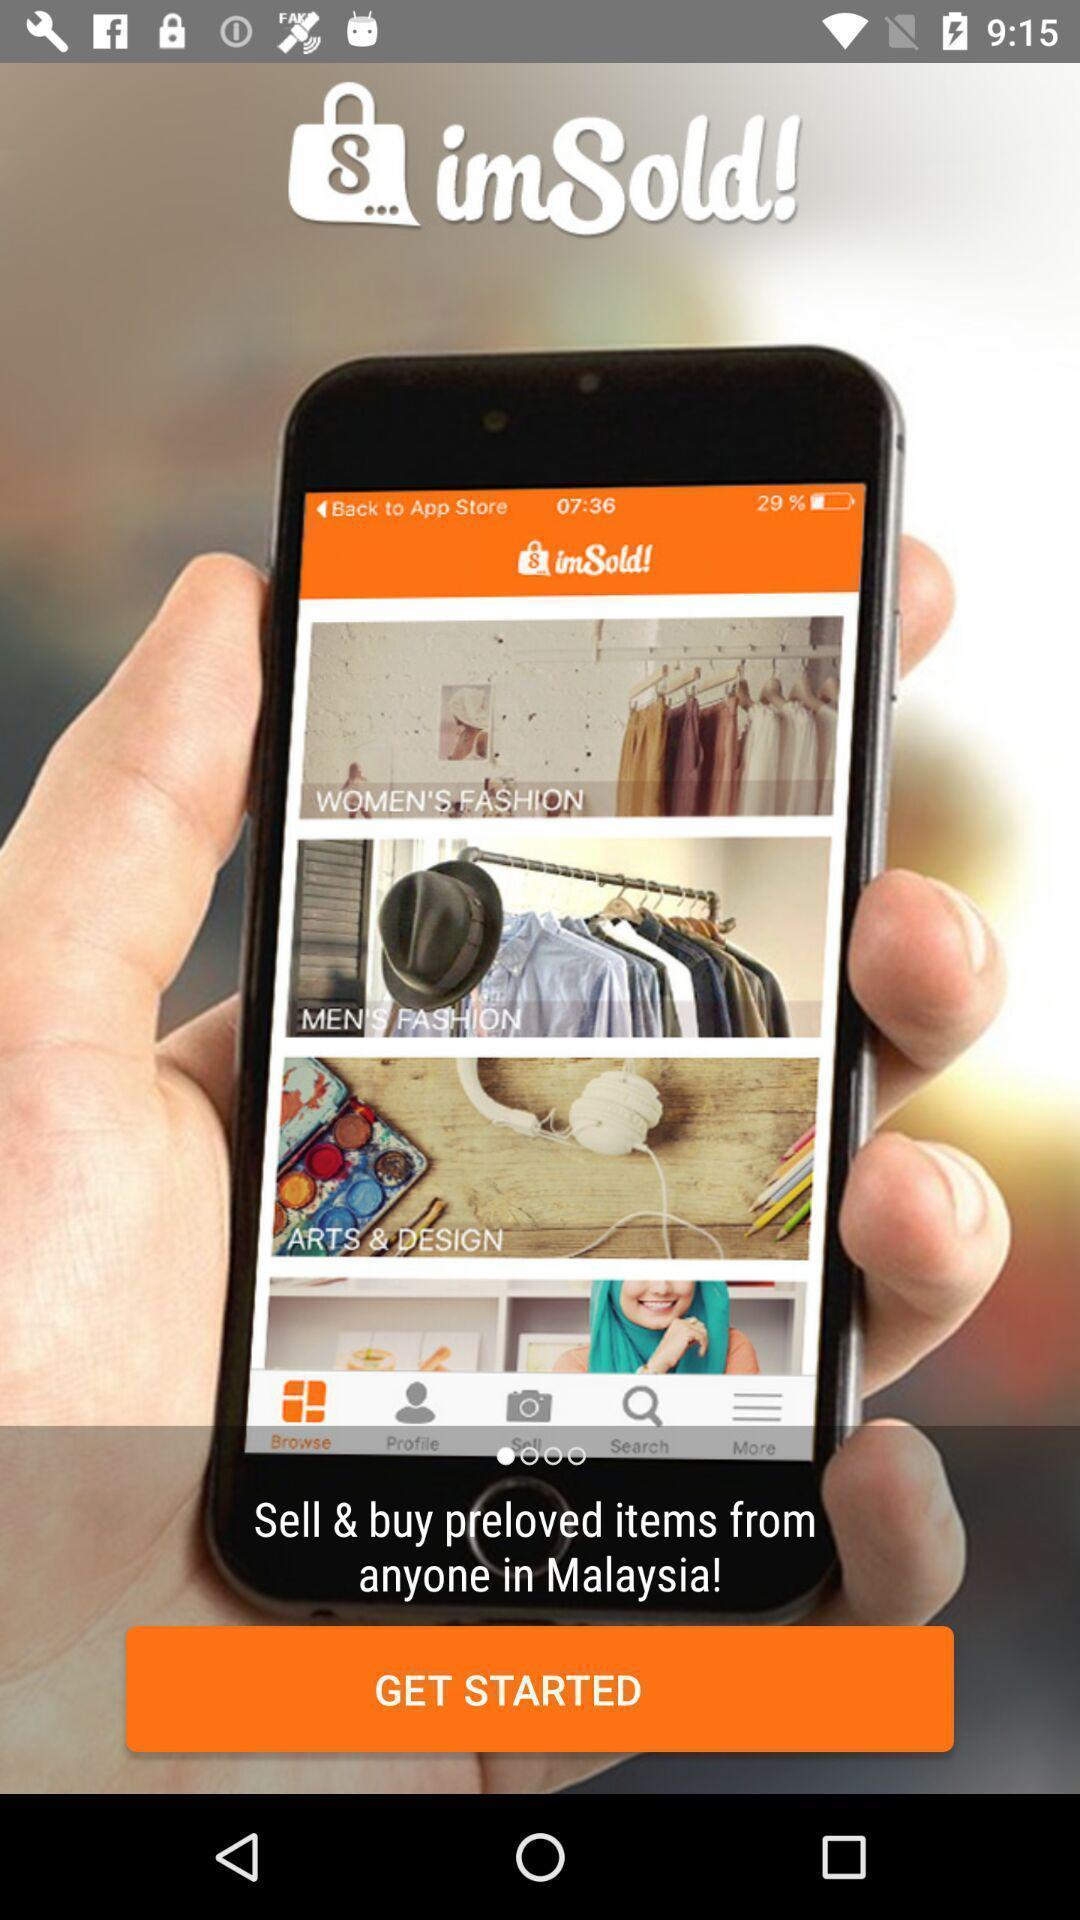Describe the visual elements of this screenshot. Welcome page of a shopping app. 